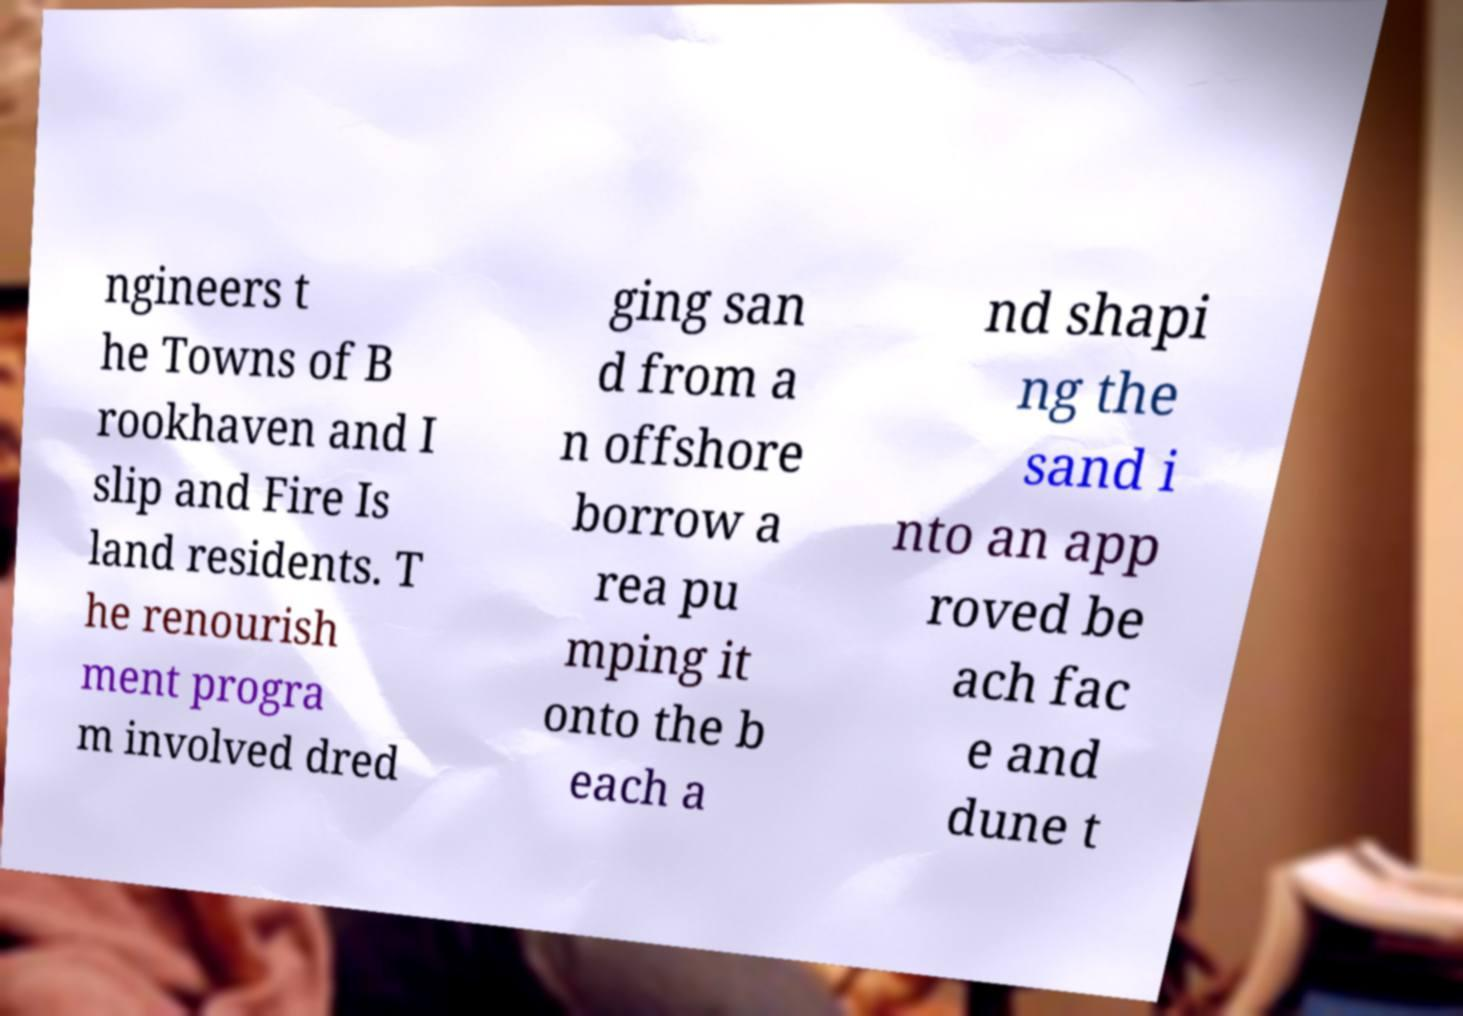For documentation purposes, I need the text within this image transcribed. Could you provide that? ngineers t he Towns of B rookhaven and I slip and Fire Is land residents. T he renourish ment progra m involved dred ging san d from a n offshore borrow a rea pu mping it onto the b each a nd shapi ng the sand i nto an app roved be ach fac e and dune t 